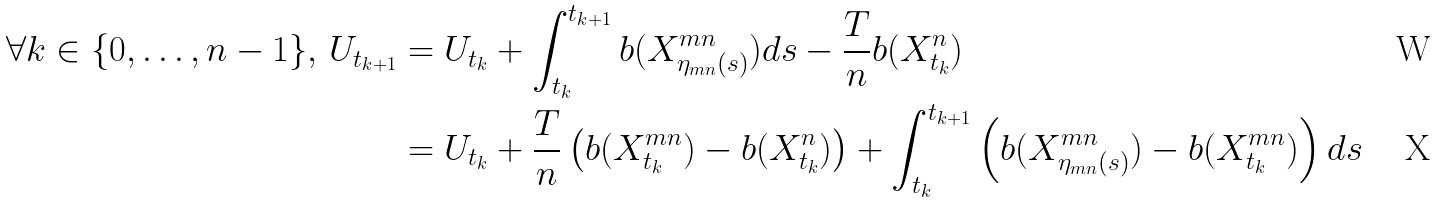Convert formula to latex. <formula><loc_0><loc_0><loc_500><loc_500>\forall k \in \{ 0 , \hdots , n - 1 \} , \, U _ { t _ { k + 1 } } & = U _ { t _ { k } } + \int _ { t _ { k } } ^ { t _ { k + 1 } } b ( X ^ { m n } _ { \eta _ { m n } ( s ) } ) d s - \frac { T } { n } b ( X ^ { n } _ { t _ { k } } ) \\ & = U _ { t _ { k } } + \frac { T } { n } \left ( b ( X ^ { m n } _ { t _ { k } } ) - b ( X ^ { n } _ { t _ { k } } ) \right ) + \int _ { t _ { k } } ^ { t _ { k + 1 } } \left ( b ( X ^ { m n } _ { \eta _ { m n } ( s ) } ) - b ( X ^ { m n } _ { t _ { k } } ) \right ) d s</formula> 